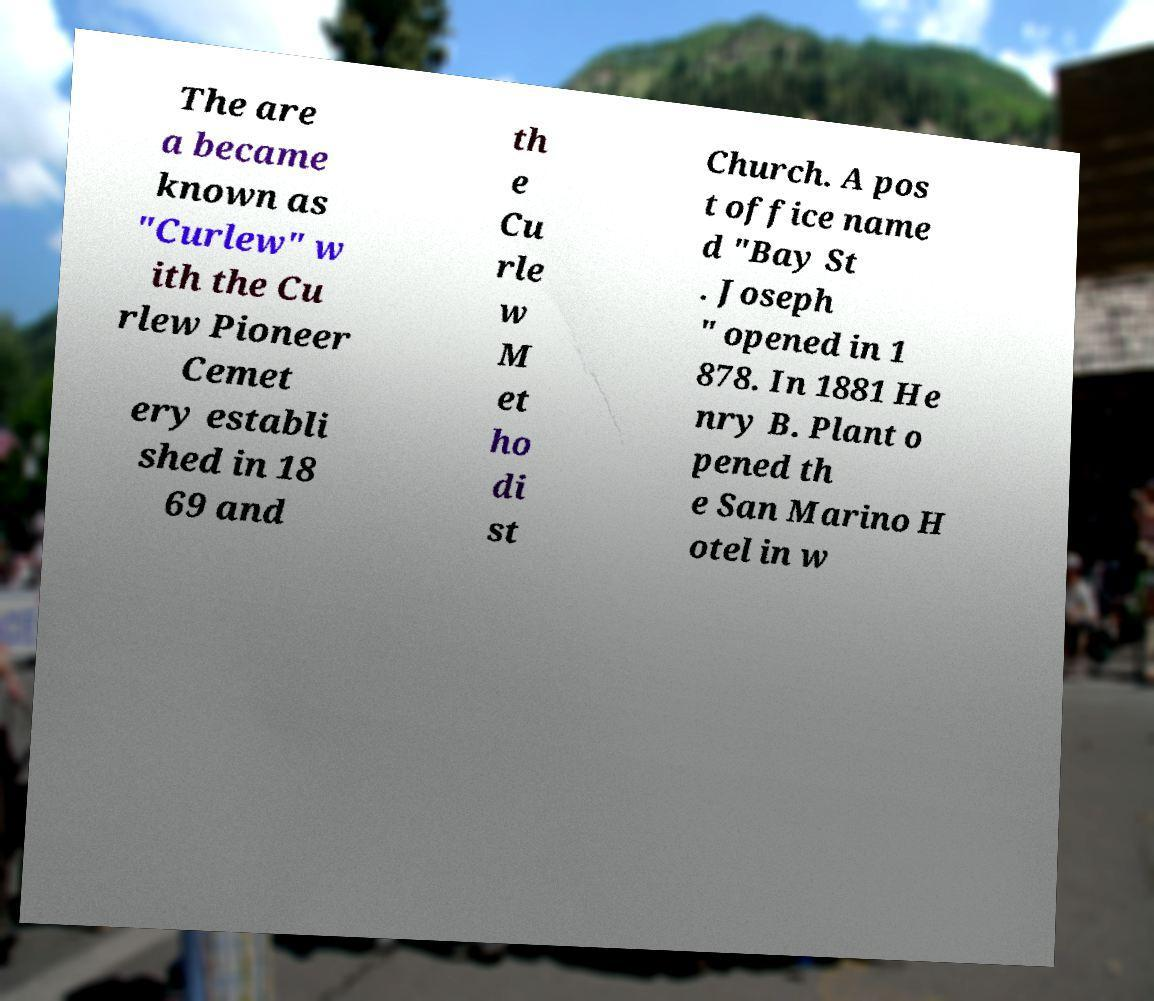Please identify and transcribe the text found in this image. The are a became known as "Curlew" w ith the Cu rlew Pioneer Cemet ery establi shed in 18 69 and th e Cu rle w M et ho di st Church. A pos t office name d "Bay St . Joseph " opened in 1 878. In 1881 He nry B. Plant o pened th e San Marino H otel in w 